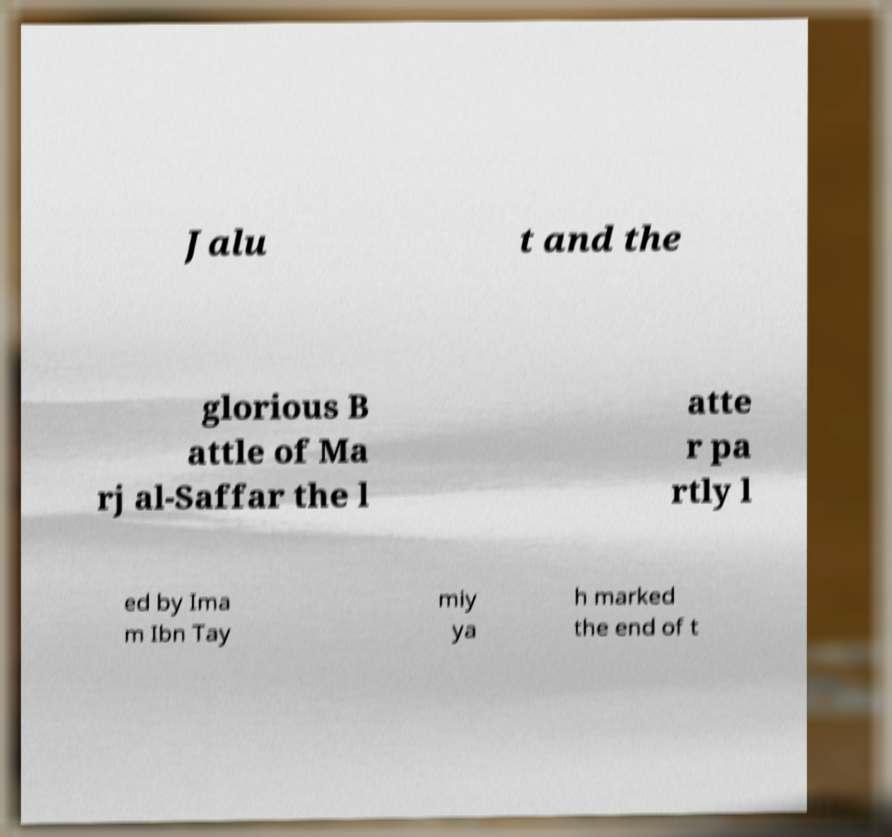Could you assist in decoding the text presented in this image and type it out clearly? Jalu t and the glorious B attle of Ma rj al-Saffar the l atte r pa rtly l ed by Ima m Ibn Tay miy ya h marked the end of t 